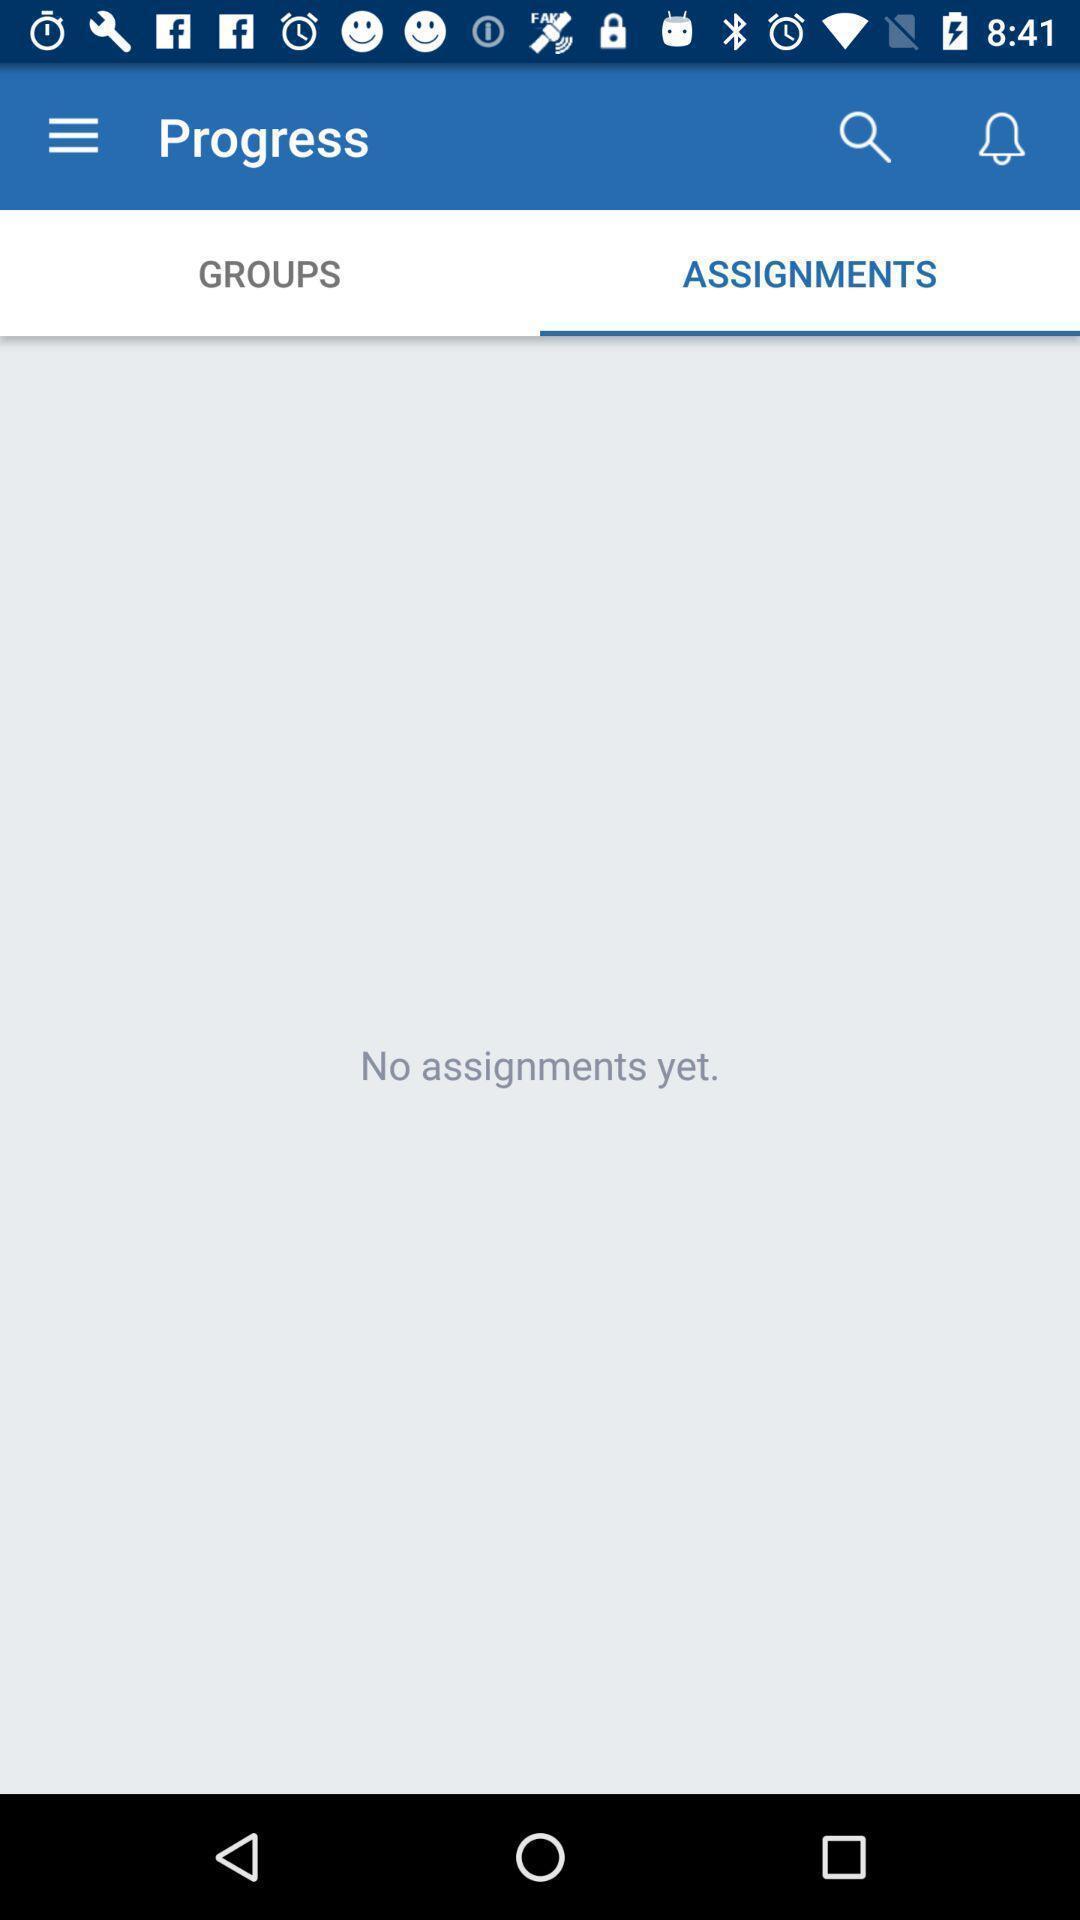What can you discern from this picture? Screen showing no assignments yet. 